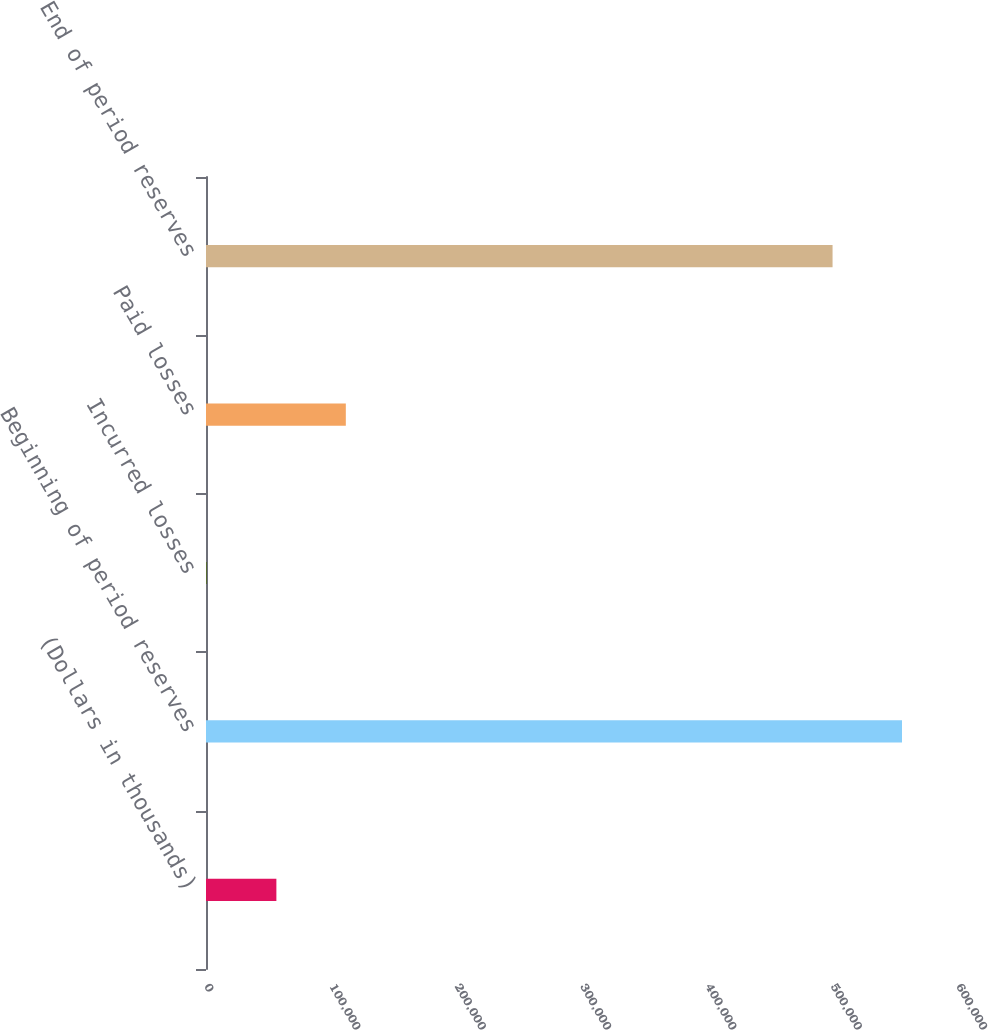Convert chart. <chart><loc_0><loc_0><loc_500><loc_500><bar_chart><fcel>(Dollars in thousands)<fcel>Beginning of period reserves<fcel>Incurred losses<fcel>Paid losses<fcel>End of period reserves<nl><fcel>56155.8<fcel>555315<fcel>752<fcel>111560<fcel>499911<nl></chart> 